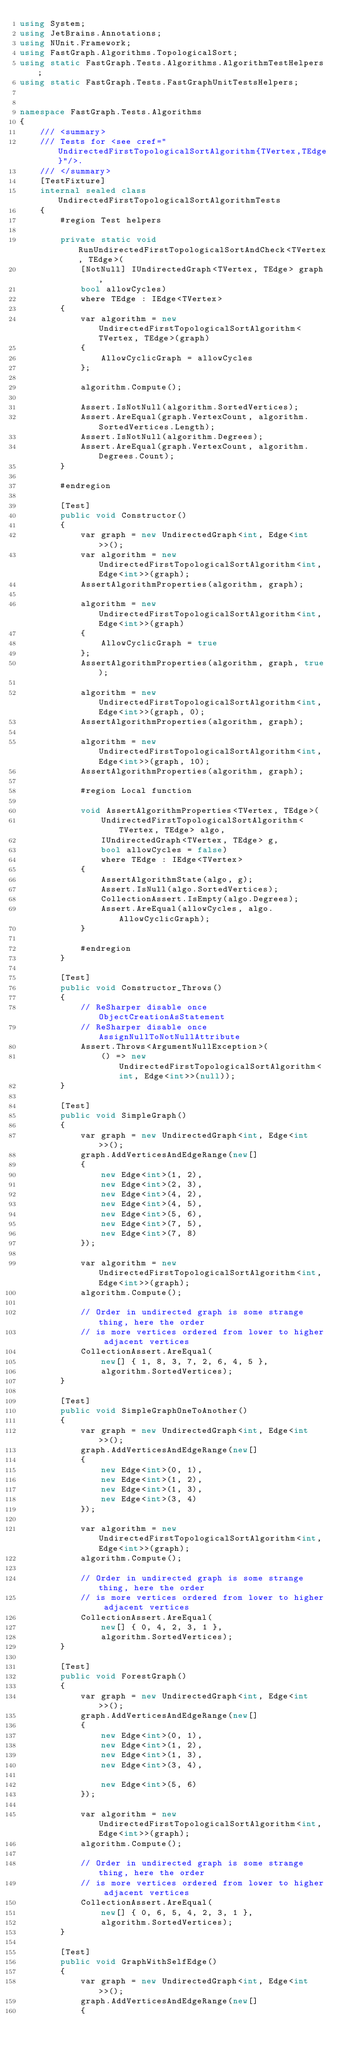<code> <loc_0><loc_0><loc_500><loc_500><_C#_>using System;
using JetBrains.Annotations;
using NUnit.Framework;
using FastGraph.Algorithms.TopologicalSort;
using static FastGraph.Tests.Algorithms.AlgorithmTestHelpers;
using static FastGraph.Tests.FastGraphUnitTestsHelpers;


namespace FastGraph.Tests.Algorithms
{
    /// <summary>
    /// Tests for <see cref="UndirectedFirstTopologicalSortAlgorithm{TVertex,TEdge}"/>.
    /// </summary>
    [TestFixture]
    internal sealed class UndirectedFirstTopologicalSortAlgorithmTests
    {
        #region Test helpers

        private static void RunUndirectedFirstTopologicalSortAndCheck<TVertex, TEdge>(
            [NotNull] IUndirectedGraph<TVertex, TEdge> graph,
            bool allowCycles)
            where TEdge : IEdge<TVertex>
        {
            var algorithm = new UndirectedFirstTopologicalSortAlgorithm<TVertex, TEdge>(graph)
            {
                AllowCyclicGraph = allowCycles
            };

            algorithm.Compute();

            Assert.IsNotNull(algorithm.SortedVertices);
            Assert.AreEqual(graph.VertexCount, algorithm.SortedVertices.Length);
            Assert.IsNotNull(algorithm.Degrees);
            Assert.AreEqual(graph.VertexCount, algorithm.Degrees.Count);
        }

        #endregion

        [Test]
        public void Constructor()
        {
            var graph = new UndirectedGraph<int, Edge<int>>();
            var algorithm = new UndirectedFirstTopologicalSortAlgorithm<int, Edge<int>>(graph);
            AssertAlgorithmProperties(algorithm, graph);

            algorithm = new UndirectedFirstTopologicalSortAlgorithm<int, Edge<int>>(graph)
            {
                AllowCyclicGraph = true
            };
            AssertAlgorithmProperties(algorithm, graph, true);

            algorithm = new UndirectedFirstTopologicalSortAlgorithm<int, Edge<int>>(graph, 0);
            AssertAlgorithmProperties(algorithm, graph);

            algorithm = new UndirectedFirstTopologicalSortAlgorithm<int, Edge<int>>(graph, 10);
            AssertAlgorithmProperties(algorithm, graph);

            #region Local function

            void AssertAlgorithmProperties<TVertex, TEdge>(
                UndirectedFirstTopologicalSortAlgorithm<TVertex, TEdge> algo,
                IUndirectedGraph<TVertex, TEdge> g,
                bool allowCycles = false)
                where TEdge : IEdge<TVertex>
            {
                AssertAlgorithmState(algo, g);
                Assert.IsNull(algo.SortedVertices);
                CollectionAssert.IsEmpty(algo.Degrees);
                Assert.AreEqual(allowCycles, algo.AllowCyclicGraph);
            }

            #endregion
        }

        [Test]
        public void Constructor_Throws()
        {
            // ReSharper disable once ObjectCreationAsStatement
            // ReSharper disable once AssignNullToNotNullAttribute
            Assert.Throws<ArgumentNullException>(
                () => new UndirectedFirstTopologicalSortAlgorithm<int, Edge<int>>(null));
        }

        [Test]
        public void SimpleGraph()
        {
            var graph = new UndirectedGraph<int, Edge<int>>();
            graph.AddVerticesAndEdgeRange(new[]
            {
                new Edge<int>(1, 2),
                new Edge<int>(2, 3),
                new Edge<int>(4, 2),
                new Edge<int>(4, 5),
                new Edge<int>(5, 6),
                new Edge<int>(7, 5),
                new Edge<int>(7, 8)
            });

            var algorithm = new UndirectedFirstTopologicalSortAlgorithm<int, Edge<int>>(graph);
            algorithm.Compute();

            // Order in undirected graph is some strange thing, here the order
            // is more vertices ordered from lower to higher adjacent vertices
            CollectionAssert.AreEqual(
                new[] { 1, 8, 3, 7, 2, 6, 4, 5 },
                algorithm.SortedVertices);
        }

        [Test]
        public void SimpleGraphOneToAnother()
        {
            var graph = new UndirectedGraph<int, Edge<int>>();
            graph.AddVerticesAndEdgeRange(new[]
            {
                new Edge<int>(0, 1),
                new Edge<int>(1, 2),
                new Edge<int>(1, 3),
                new Edge<int>(3, 4)
            });

            var algorithm = new UndirectedFirstTopologicalSortAlgorithm<int, Edge<int>>(graph);
            algorithm.Compute();

            // Order in undirected graph is some strange thing, here the order
            // is more vertices ordered from lower to higher adjacent vertices
            CollectionAssert.AreEqual(
                new[] { 0, 4, 2, 3, 1 },
                algorithm.SortedVertices);
        }

        [Test]
        public void ForestGraph()
        {
            var graph = new UndirectedGraph<int, Edge<int>>();
            graph.AddVerticesAndEdgeRange(new[]
            {
                new Edge<int>(0, 1),
                new Edge<int>(1, 2),
                new Edge<int>(1, 3),
                new Edge<int>(3, 4),

                new Edge<int>(5, 6)
            });

            var algorithm = new UndirectedFirstTopologicalSortAlgorithm<int, Edge<int>>(graph);
            algorithm.Compute();

            // Order in undirected graph is some strange thing, here the order
            // is more vertices ordered from lower to higher adjacent vertices
            CollectionAssert.AreEqual(
                new[] { 0, 6, 5, 4, 2, 3, 1 },
                algorithm.SortedVertices);
        }

        [Test]
        public void GraphWithSelfEdge()
        {
            var graph = new UndirectedGraph<int, Edge<int>>();
            graph.AddVerticesAndEdgeRange(new[]
            {</code> 